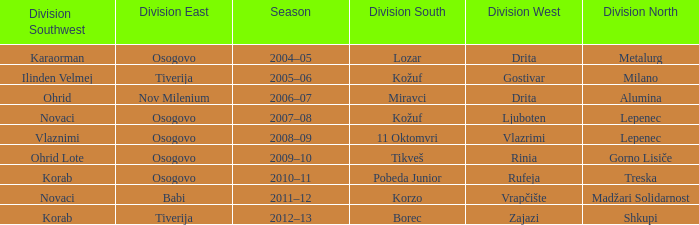Who won Division West when Division North was won by Alumina? Drita. 